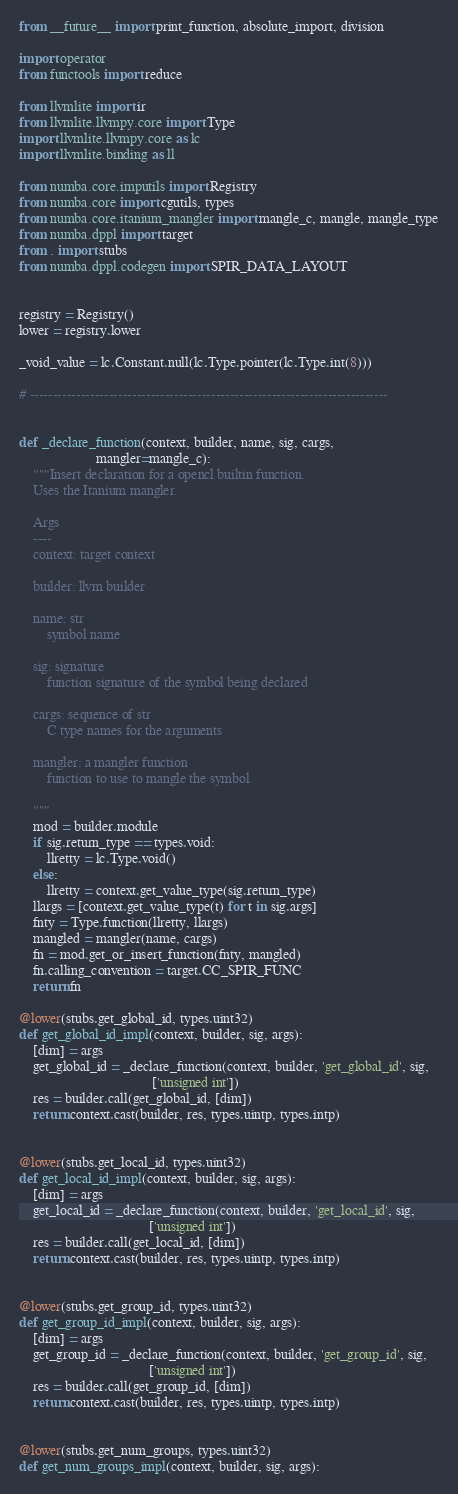<code> <loc_0><loc_0><loc_500><loc_500><_Python_>from __future__ import print_function, absolute_import, division

import operator
from functools import reduce

from llvmlite import ir
from llvmlite.llvmpy.core import Type
import llvmlite.llvmpy.core as lc
import llvmlite.binding as ll

from numba.core.imputils import Registry
from numba.core import cgutils, types
from numba.core.itanium_mangler import mangle_c, mangle, mangle_type
from numba.dppl import target
from . import stubs
from numba.dppl.codegen import SPIR_DATA_LAYOUT


registry = Registry()
lower = registry.lower

_void_value = lc.Constant.null(lc.Type.pointer(lc.Type.int(8)))

# -----------------------------------------------------------------------------


def _declare_function(context, builder, name, sig, cargs,
                      mangler=mangle_c):
    """Insert declaration for a opencl builtin function.
    Uses the Itanium mangler.

    Args
    ----
    context: target context

    builder: llvm builder

    name: str
        symbol name

    sig: signature
        function signature of the symbol being declared

    cargs: sequence of str
        C type names for the arguments

    mangler: a mangler function
        function to use to mangle the symbol

    """
    mod = builder.module
    if sig.return_type == types.void:
        llretty = lc.Type.void()
    else:
        llretty = context.get_value_type(sig.return_type)
    llargs = [context.get_value_type(t) for t in sig.args]
    fnty = Type.function(llretty, llargs)
    mangled = mangler(name, cargs)
    fn = mod.get_or_insert_function(fnty, mangled)
    fn.calling_convention = target.CC_SPIR_FUNC
    return fn

@lower(stubs.get_global_id, types.uint32)
def get_global_id_impl(context, builder, sig, args):
    [dim] = args
    get_global_id = _declare_function(context, builder, 'get_global_id', sig,
                                      ['unsigned int'])
    res = builder.call(get_global_id, [dim])
    return context.cast(builder, res, types.uintp, types.intp)


@lower(stubs.get_local_id, types.uint32)
def get_local_id_impl(context, builder, sig, args):
    [dim] = args
    get_local_id = _declare_function(context, builder, 'get_local_id', sig,
                                     ['unsigned int'])
    res = builder.call(get_local_id, [dim])
    return context.cast(builder, res, types.uintp, types.intp)


@lower(stubs.get_group_id, types.uint32)
def get_group_id_impl(context, builder, sig, args):
    [dim] = args
    get_group_id = _declare_function(context, builder, 'get_group_id', sig,
                                     ['unsigned int'])
    res = builder.call(get_group_id, [dim])
    return context.cast(builder, res, types.uintp, types.intp)


@lower(stubs.get_num_groups, types.uint32)
def get_num_groups_impl(context, builder, sig, args):</code> 